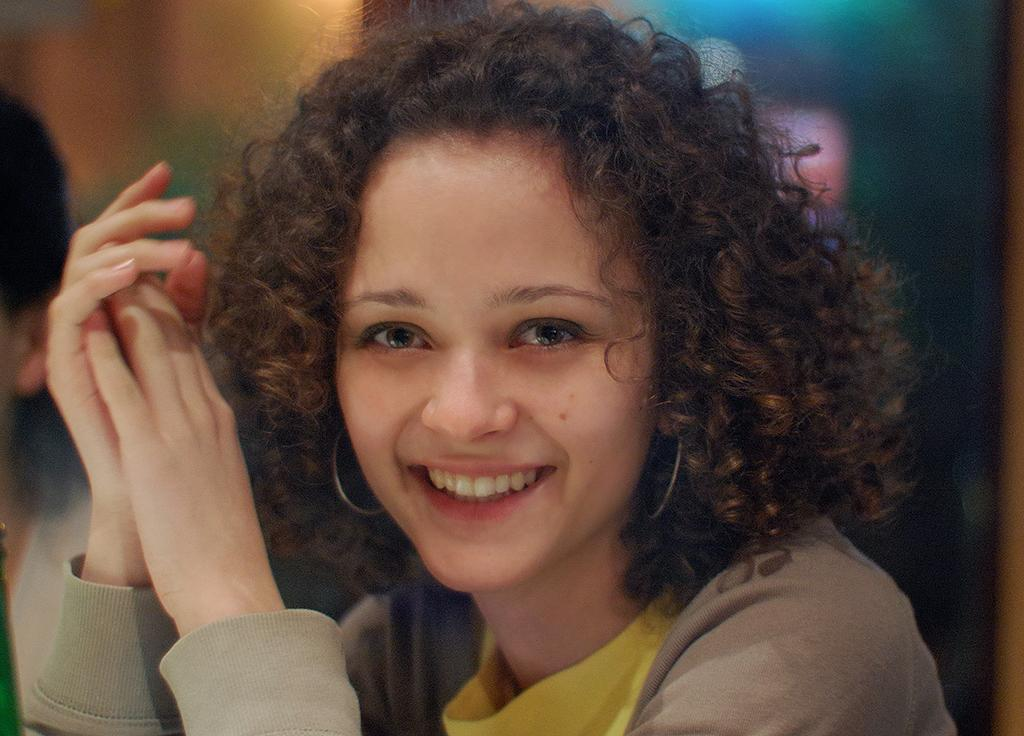Who is present in the image? There is a woman in the image. What is the woman doing in the image? The woman is smiling in the image. Can you describe the background of the image? The background of the image is blurred. Are there any other people visible in the image? Yes, there is another person in the left corner of the image. What type of fear can be seen on the woman's face in the image? There is no fear visible on the woman's face in the image; she is smiling. How many chairs are present in the image? There is no mention of chairs in the image, so it is impossible to determine their number. 